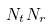Convert formula to latex. <formula><loc_0><loc_0><loc_500><loc_500>N _ { t } N _ { r }</formula> 